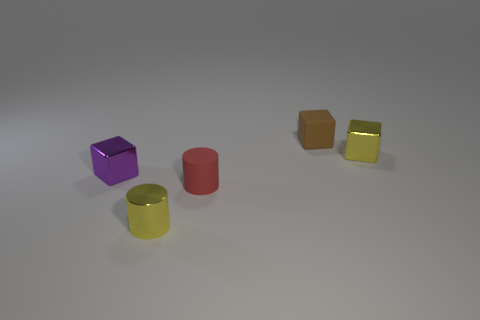There is a tiny cube that is left of the shiny cylinder; does it have the same color as the small metal cylinder?
Offer a terse response. No. There is a small cube that is to the left of the tiny yellow metallic block and in front of the matte block; what is its color?
Make the answer very short. Purple. What is the shape of the red object that is the same size as the yellow cylinder?
Provide a short and direct response. Cylinder. Are there any other tiny things that have the same shape as the tiny purple thing?
Offer a very short reply. Yes. There is a rubber object behind the purple metallic object; is it the same size as the metal cylinder?
Give a very brief answer. Yes. There is a thing that is both behind the tiny purple object and in front of the brown thing; what size is it?
Your response must be concise. Small. What number of other things are there of the same material as the small purple object
Offer a terse response. 2. How big is the shiny block that is behind the purple metallic block?
Offer a terse response. Small. Does the metallic cylinder have the same color as the rubber cube?
Offer a terse response. No. What number of tiny things are brown metal spheres or metallic things?
Give a very brief answer. 3. 